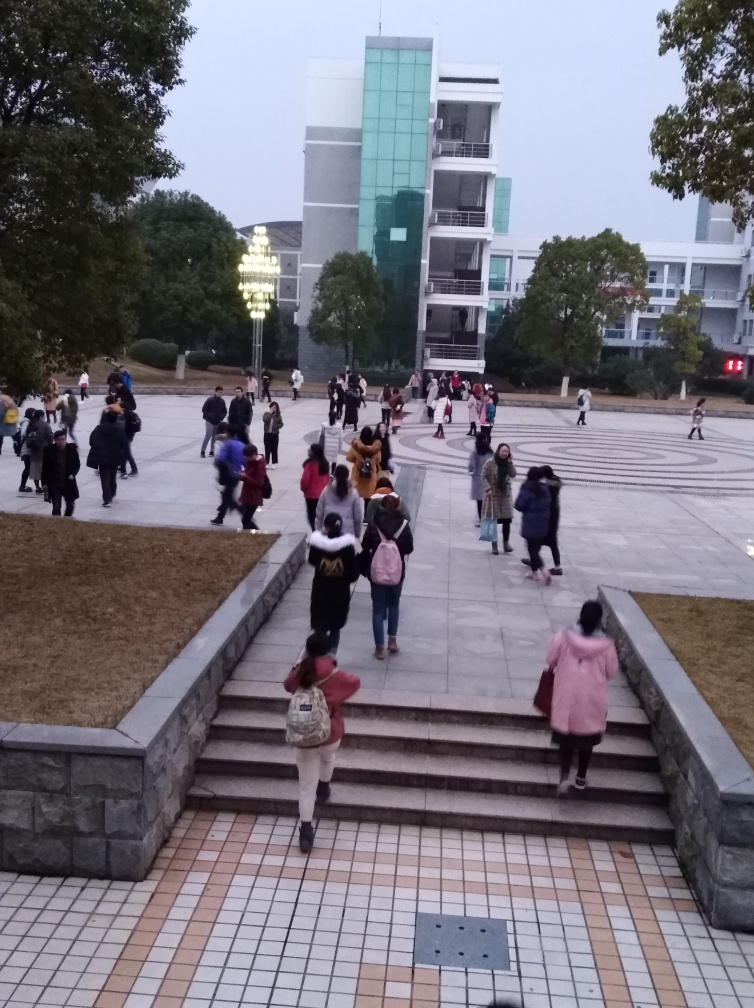What time of day does this image appear to have been taken? Given the subdued lighting and absence of harsh shadows, the image appears to have been taken either in the early morning or late evening. The sky is overcast, suggesting that the sun is not visible, which makes it difficult to ascertain the exact time of day with certainty. 